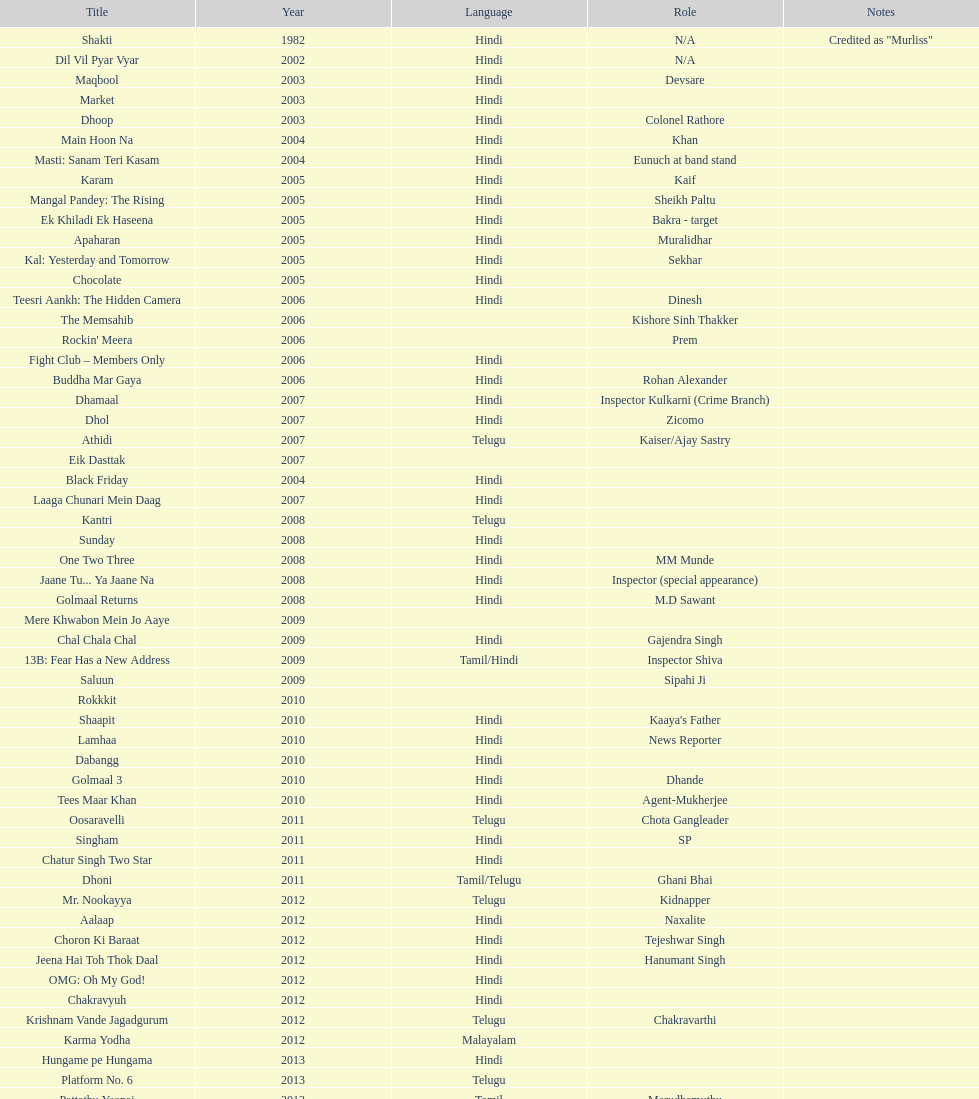How many roles has this actor had? 36. 